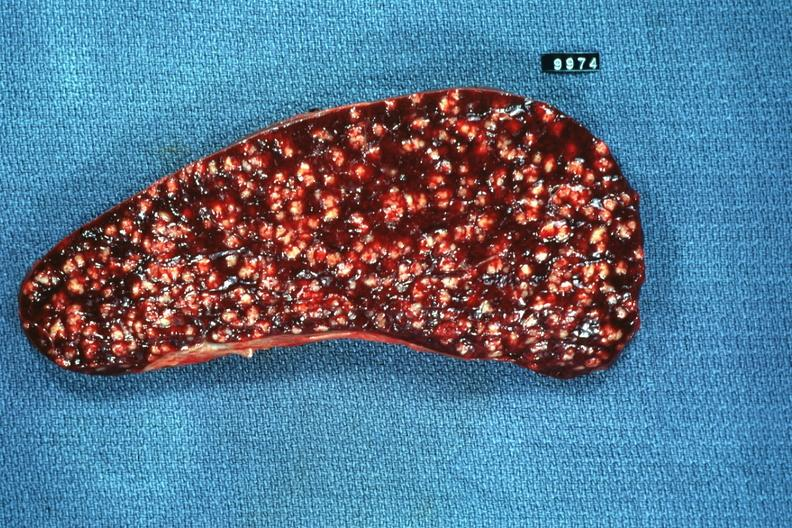what is present?
Answer the question using a single word or phrase. Hematologic 